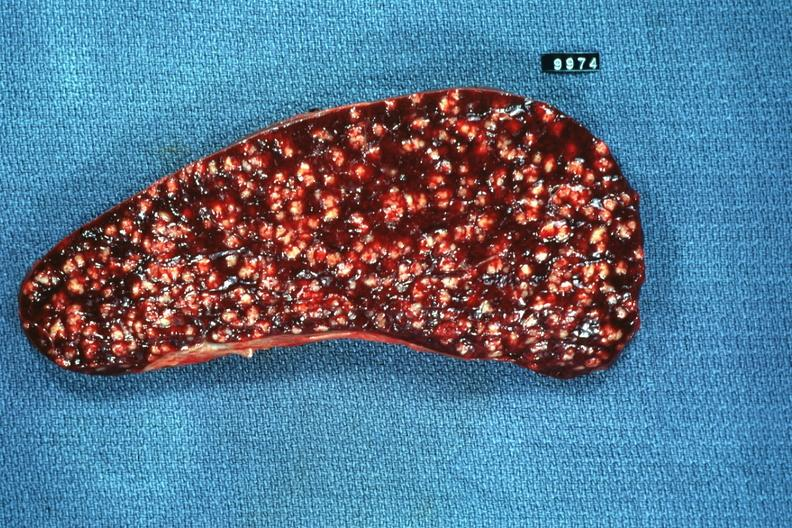what is present?
Answer the question using a single word or phrase. Hematologic 